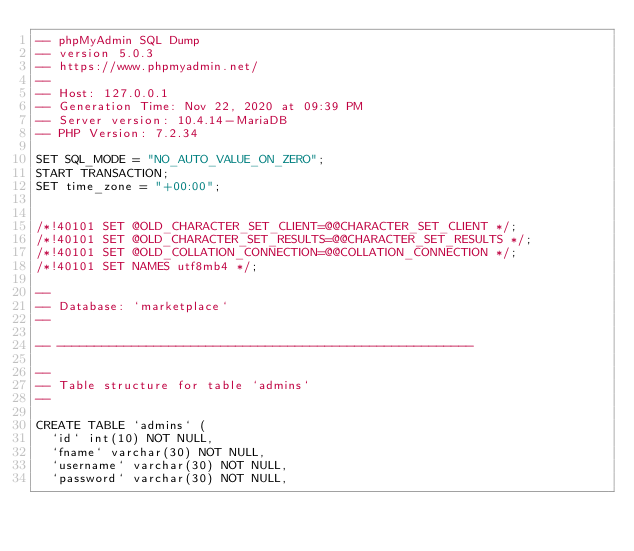<code> <loc_0><loc_0><loc_500><loc_500><_SQL_>-- phpMyAdmin SQL Dump
-- version 5.0.3
-- https://www.phpmyadmin.net/
--
-- Host: 127.0.0.1
-- Generation Time: Nov 22, 2020 at 09:39 PM
-- Server version: 10.4.14-MariaDB
-- PHP Version: 7.2.34

SET SQL_MODE = "NO_AUTO_VALUE_ON_ZERO";
START TRANSACTION;
SET time_zone = "+00:00";


/*!40101 SET @OLD_CHARACTER_SET_CLIENT=@@CHARACTER_SET_CLIENT */;
/*!40101 SET @OLD_CHARACTER_SET_RESULTS=@@CHARACTER_SET_RESULTS */;
/*!40101 SET @OLD_COLLATION_CONNECTION=@@COLLATION_CONNECTION */;
/*!40101 SET NAMES utf8mb4 */;

--
-- Database: `marketplace`
--

-- --------------------------------------------------------

--
-- Table structure for table `admins`
--

CREATE TABLE `admins` (
  `id` int(10) NOT NULL,
  `fname` varchar(30) NOT NULL,
  `username` varchar(30) NOT NULL,
  `password` varchar(30) NOT NULL,</code> 